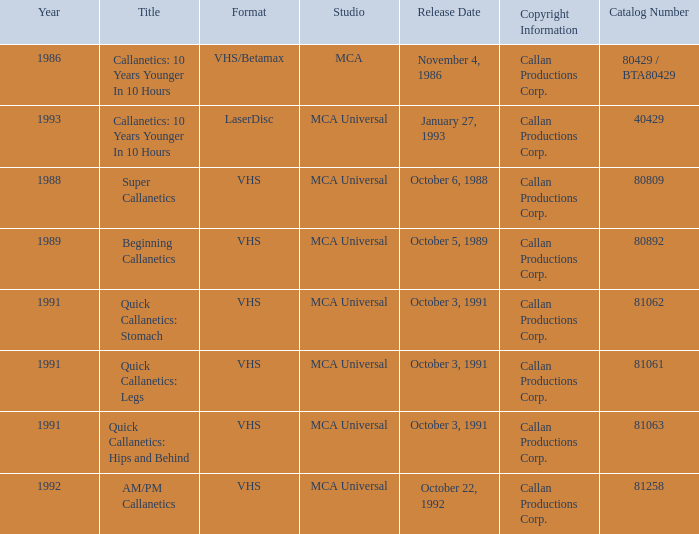Name the format for  quick callanetics: hips and behind VHS. 